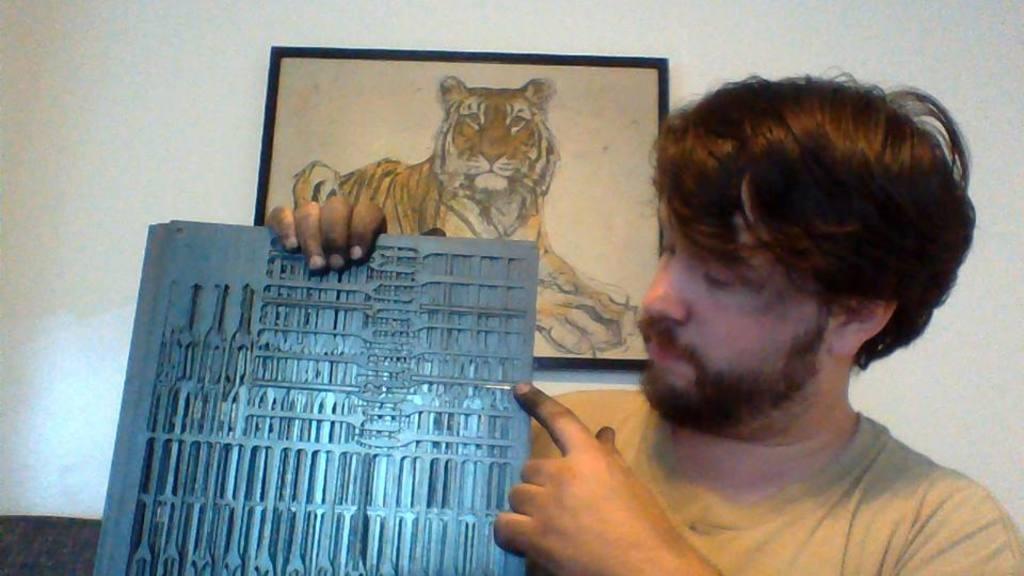In one or two sentences, can you explain what this image depicts? In this image I can see a person is holding an object in hand. In the background I can see a wall and a photo frame. This image is taken may be in a room. 